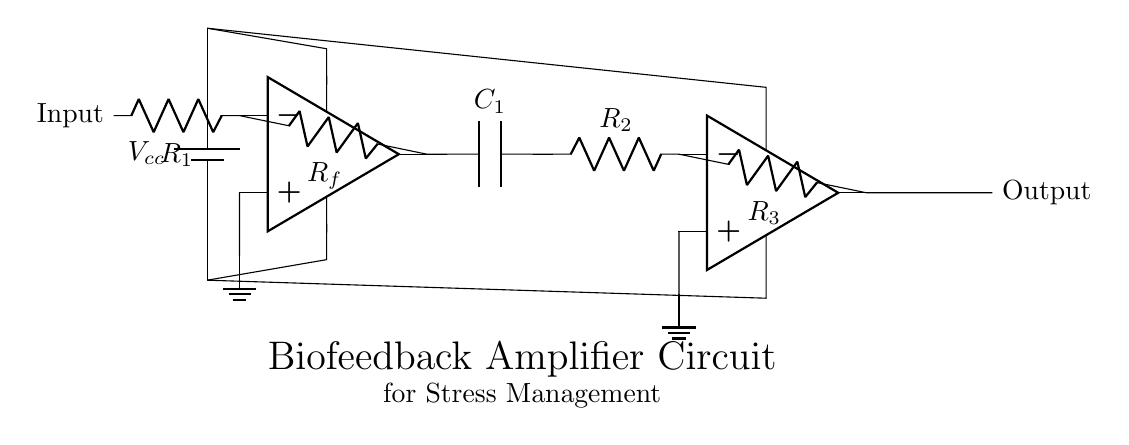What type of amplifiers are used in this circuit? The circuit has two operational amplifiers (op amps) in a cascading configuration, serving as amplifiers.
Answer: operational amplifiers What is the function of the capacitor in this circuit? The capacitor (C1) is used for AC coupling, allowing AC signals to pass while blocking DC, ensuring only the desired amplitude variations are amplified.
Answer: coupling What is the purpose of the feedback resistor Rf in the first op amp? The feedback resistor Rf is used to set the gain of the first operational amplifier; it takes a portion of the output and feeds it back to the inverting input.
Answer: gain control How many resistors are present in the circuit? There are three resistors (R1, Rf, R2, and R3) in the circuit providing different functions for gain and stability.
Answer: four What happens to the output if the feedback resistor Rf is removed? Removing Rf would likely cause the op amp to operate in an open-loop configuration, which can lead to instability and saturation, making it ineffective for amplification.
Answer: instability What is the significance of grounding in this circuit? Grounding provides a reference point for the voltages in the circuit, enabling proper functioning of the operational amplifiers by ensuring that they each have a common reference point for signal processing.
Answer: reference point What kind of application does this amplifier circuit serve? The amplifier circuit is designed for a biofeedback device aimed at stress management by amplifying physiological signals for analysis.
Answer: biofeedback 